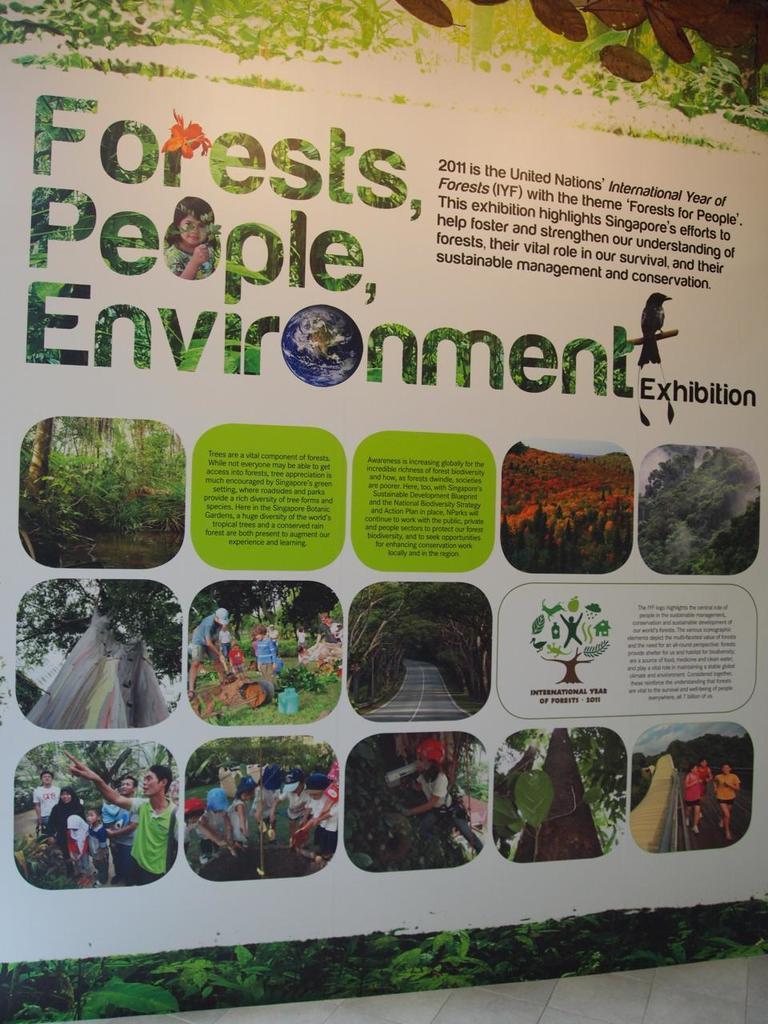Could you give a brief overview of what you see in this image? The picture consists of a poster. In the poster there are images and text. In the images there are trees, people, roads and other objects. At the top and at the bottom there are trees. 